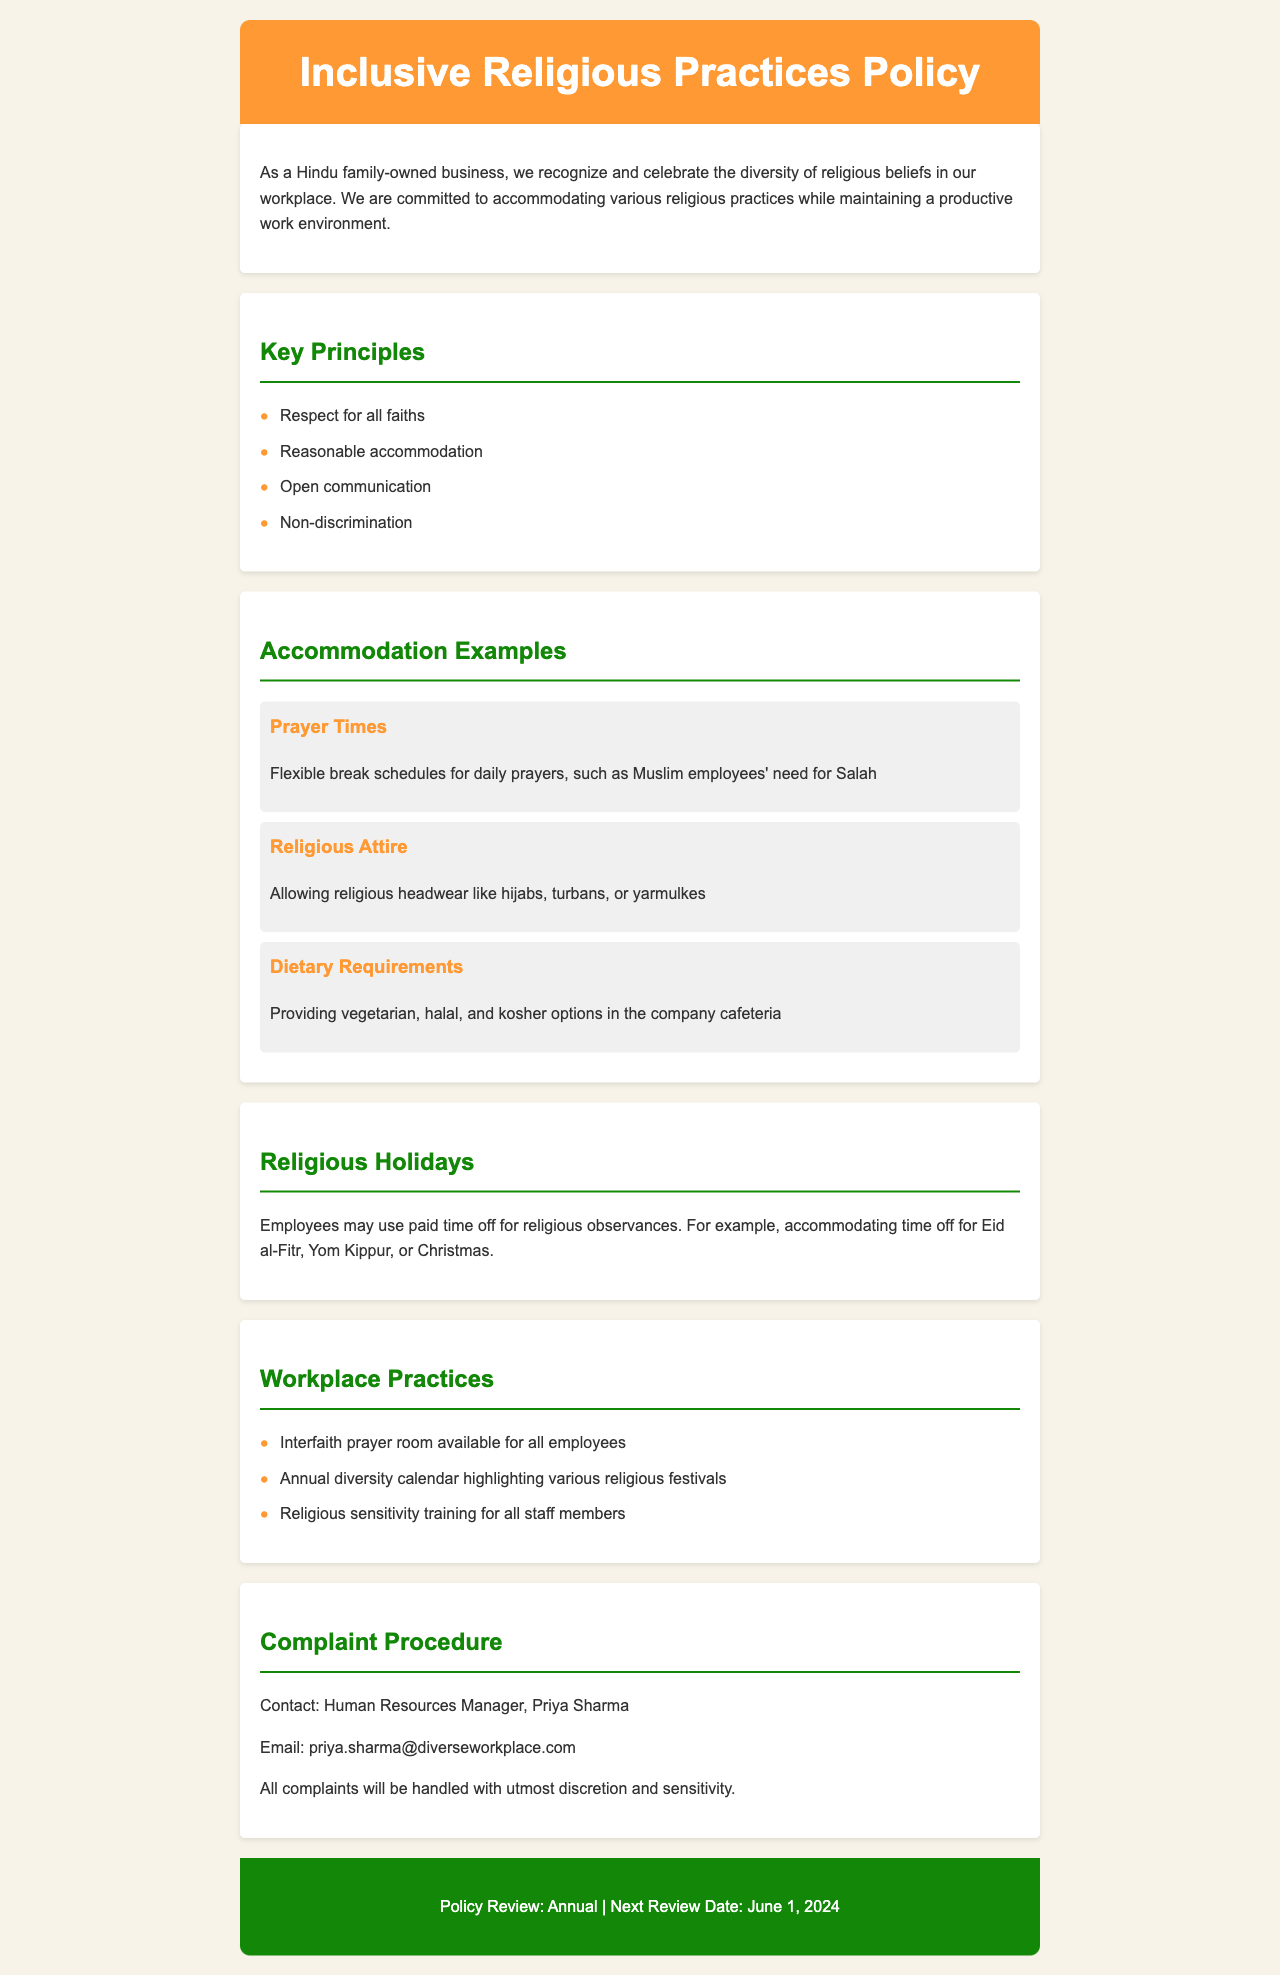What is the title of the policy document? The title is located in the header section of the document.
Answer: Inclusive Religious Practices Policy Who is the Human Resources Manager mentioned in the complaint procedure? The Human Resources Manager's name is specified in the complaint procedure section.
Answer: Priya Sharma What type of room is available for all employees? This information is found in the workplace practices section.
Answer: Interfaith prayer room How often is the policy reviewed? The review frequency is mentioned in the footer of the document.
Answer: Annual What does the company provide in terms of dietary requirements? This is listed under the accommodation examples section.
Answer: Vegetarian, halal, and kosher options How can employees contact the Human Resources Manager? The contact information is provided in the complaint procedure section.
Answer: Email: priya.sharma@diverseworkplace.com What date is the next policy review scheduled for? The next review date is stated in the footer section.
Answer: June 1, 2024 What is a key principle related to religious beliefs in the workplace? Key principles are outlined in the key principles section.
Answer: Respect for all faiths Which religious holiday does the policy specifically mention for time off? The example of a religious holiday is given in the religious holidays section.
Answer: Eid al-Fitr 